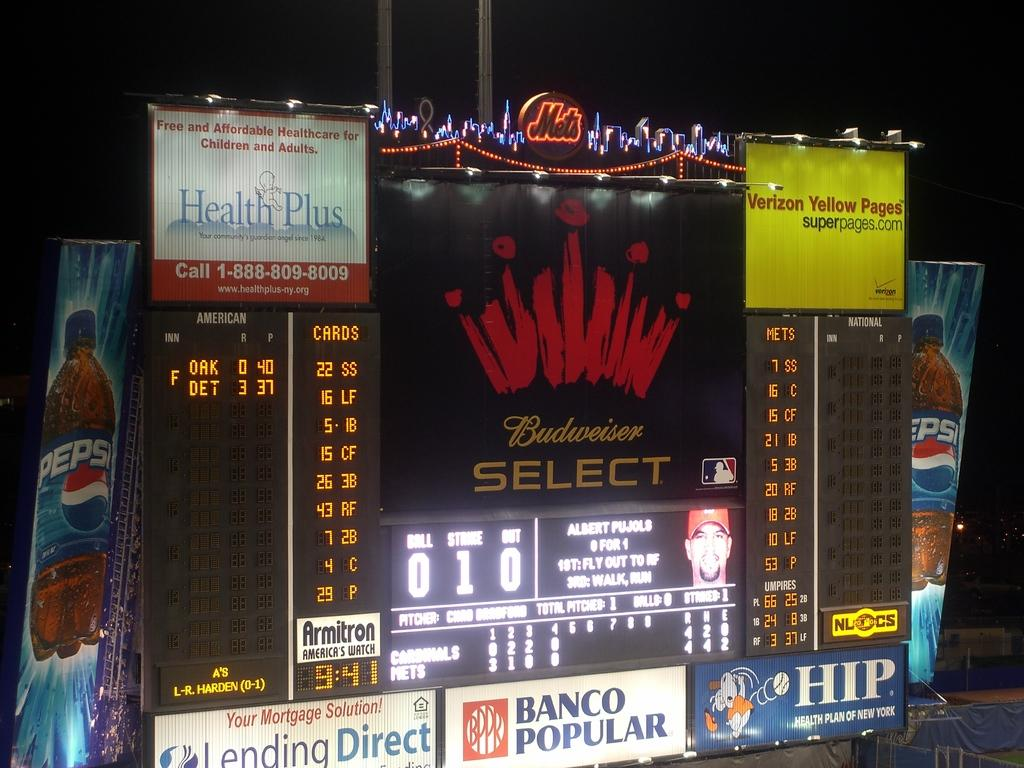<image>
Relay a brief, clear account of the picture shown. an outfield baseball sign with budweiser select being advertised 